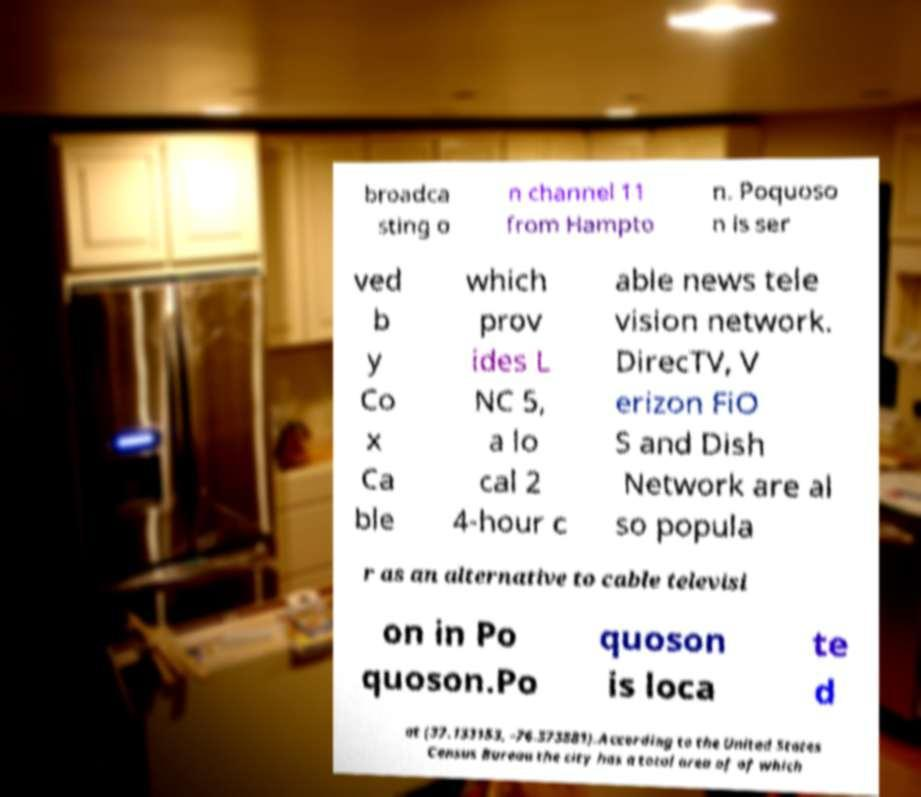Can you accurately transcribe the text from the provided image for me? broadca sting o n channel 11 from Hampto n. Poquoso n is ser ved b y Co x Ca ble which prov ides L NC 5, a lo cal 2 4-hour c able news tele vision network. DirecTV, V erizon FiO S and Dish Network are al so popula r as an alternative to cable televisi on in Po quoson.Po quoson is loca te d at (37.133153, -76.373881).According to the United States Census Bureau the city has a total area of of which 